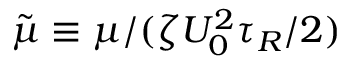<formula> <loc_0><loc_0><loc_500><loc_500>\tilde { \mu } \equiv \mu / ( \zeta U _ { 0 } ^ { 2 } \tau _ { R } / 2 )</formula> 